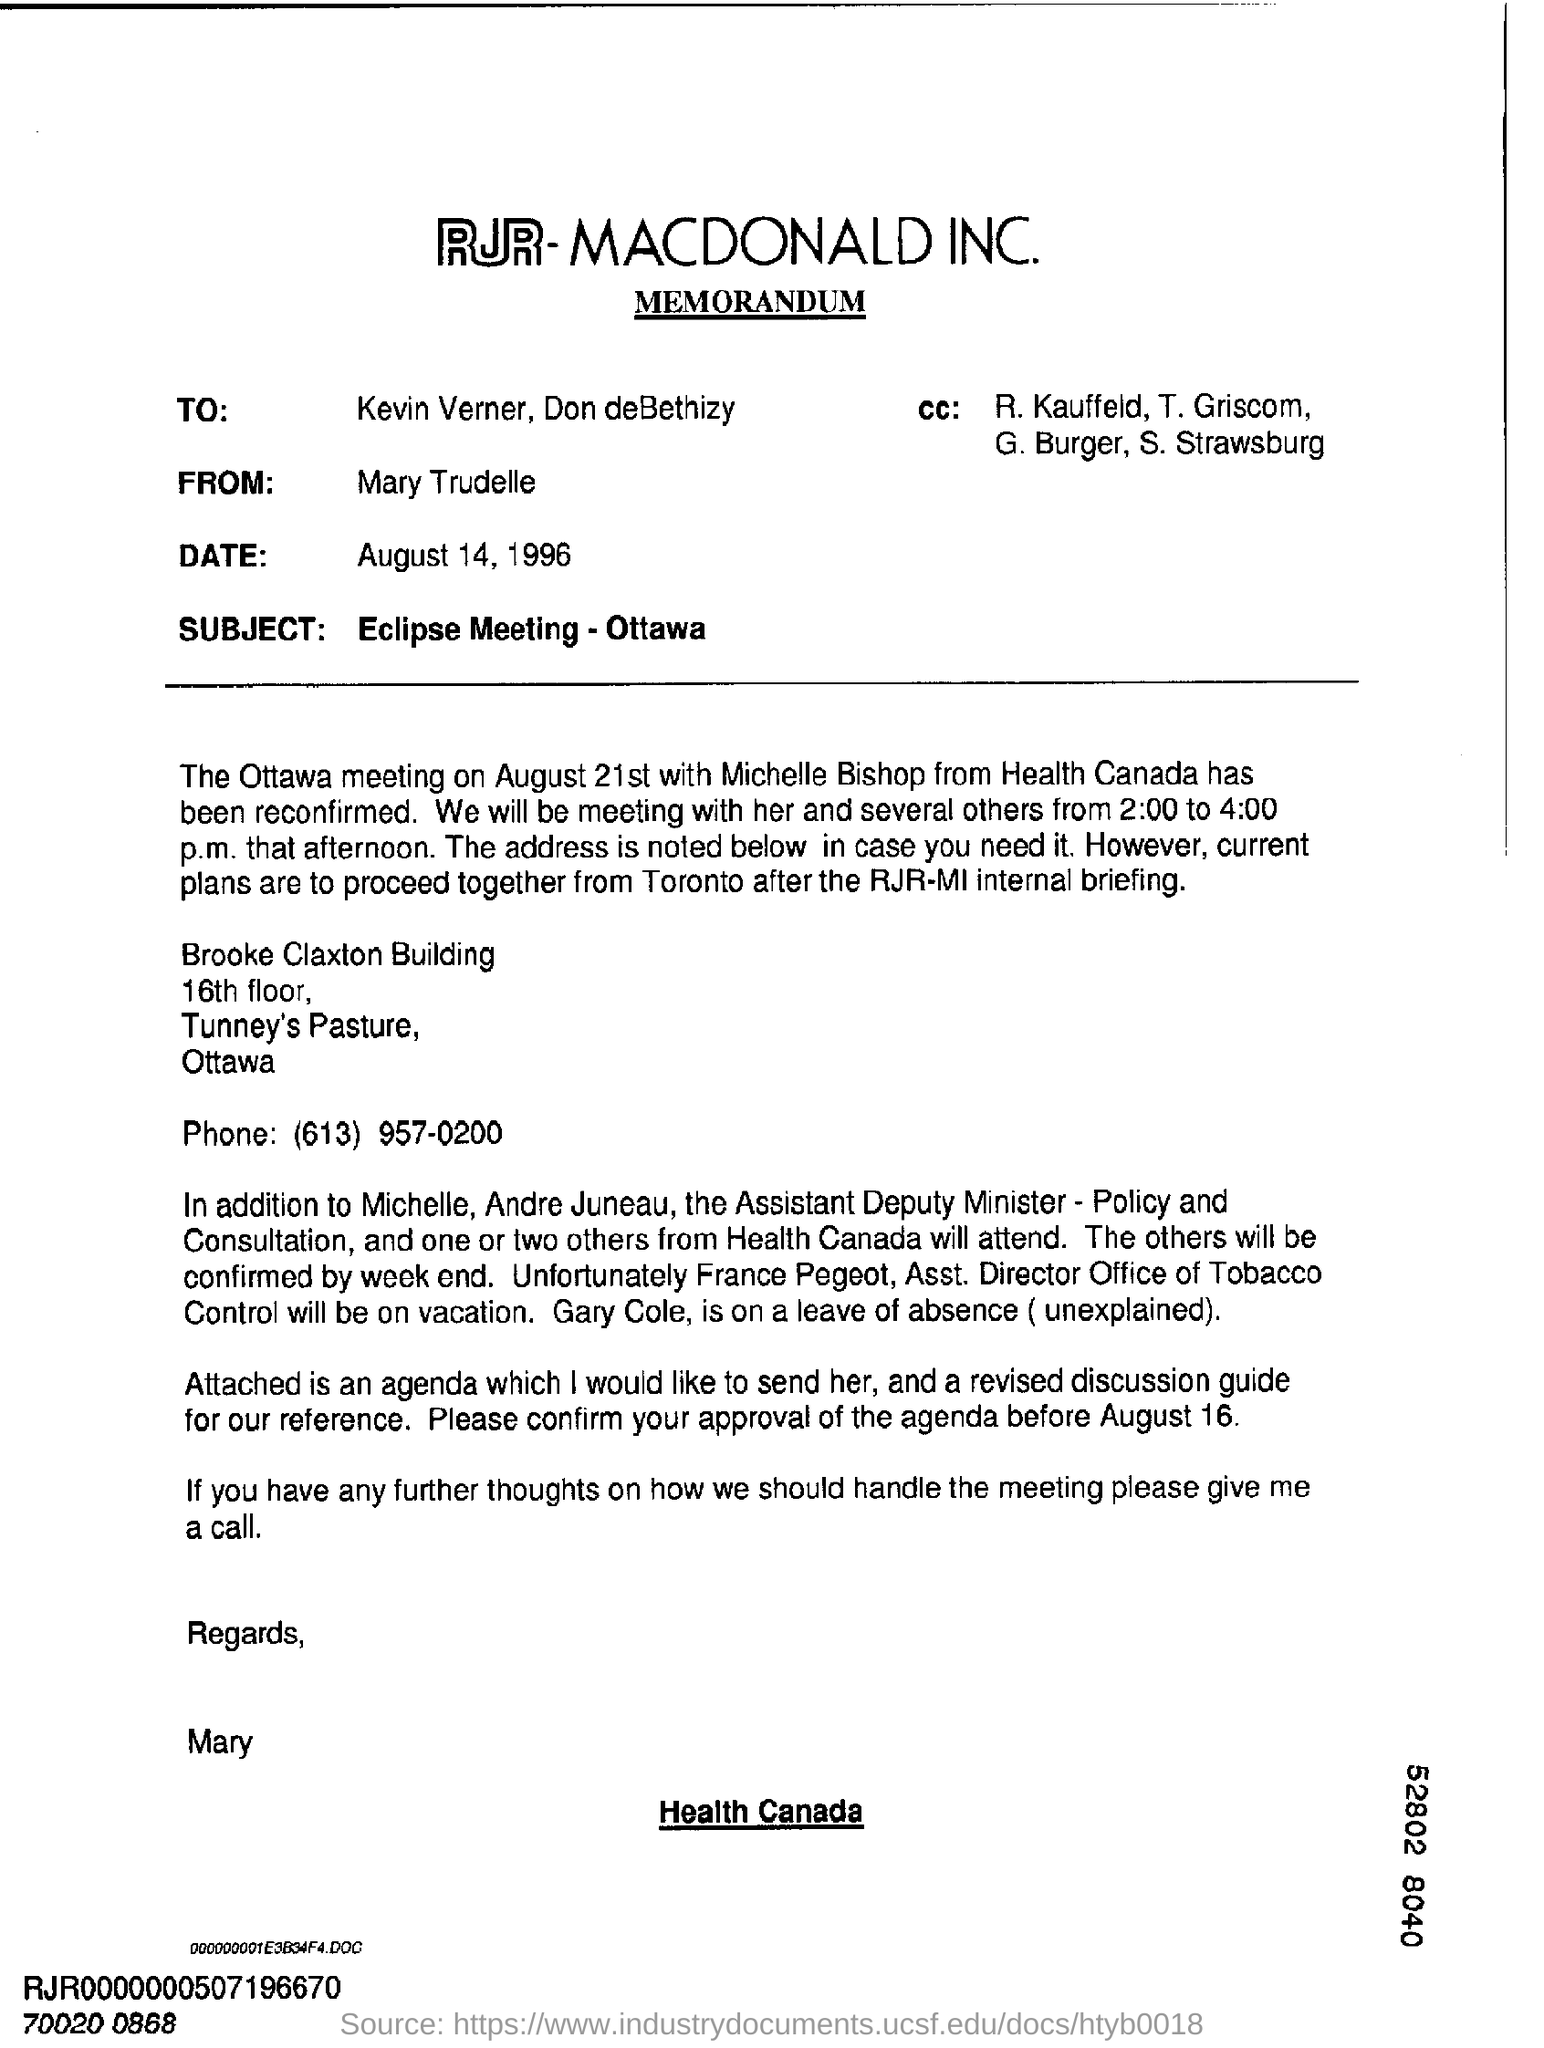Indicate a few pertinent items in this graphic. The subject of the memorandum is the upcoming Eclipse Meeting to be held in Ottawa. Mary Trudelle is writing this memorandum for Kevin Verner and Don deBethizy. France's designation is Pegeot, and the Assistant Director of the Office of Tobacco Control is Ms. Director of Tobacco Control. The memorandum indicates that the date is August 14, 1996. Michelle and Andre Juneau are the Assistant Deputy Minister. 